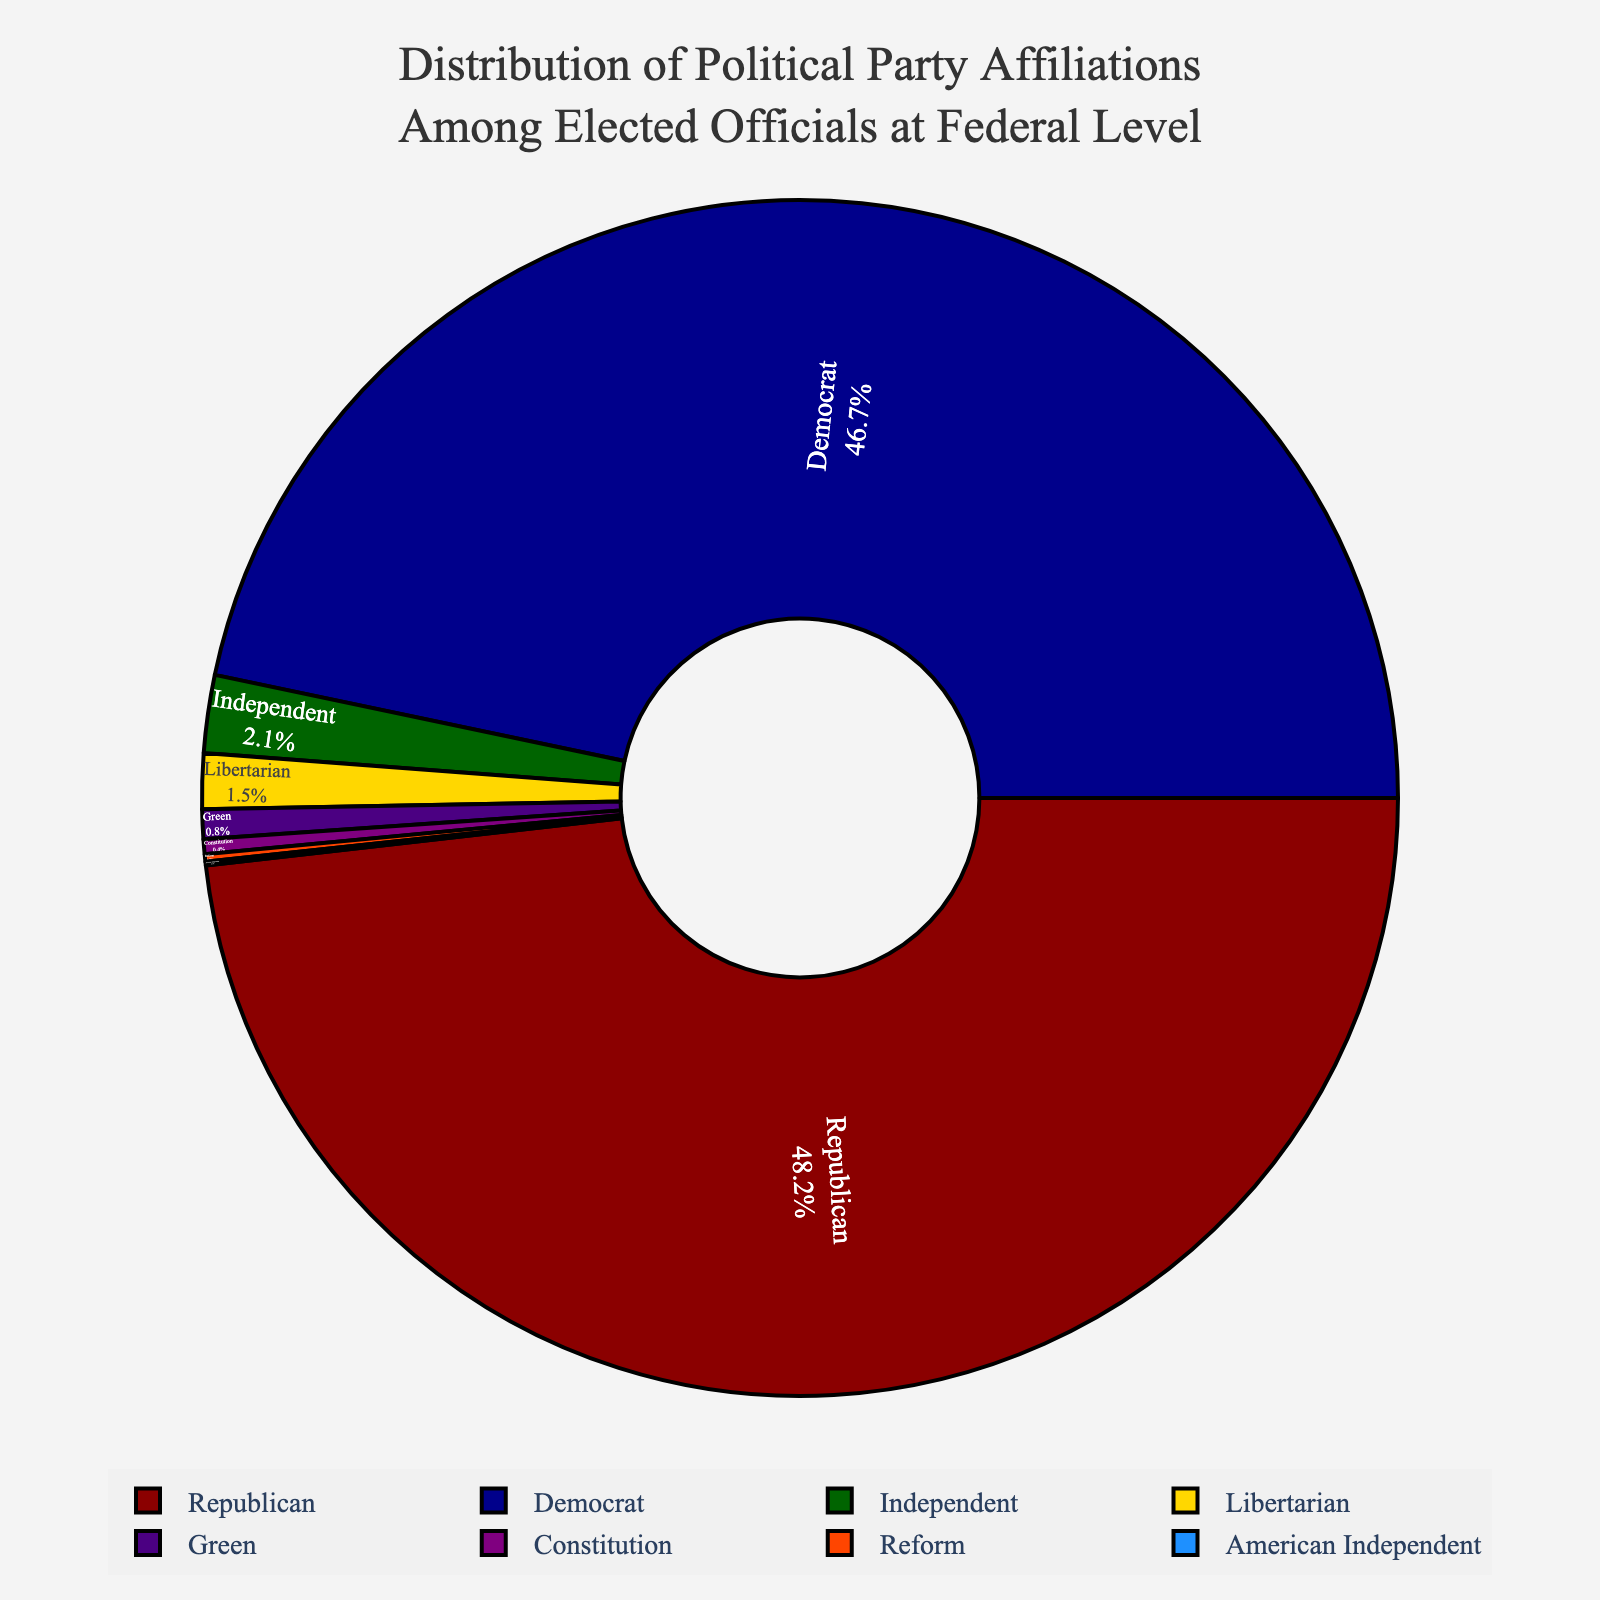What's the total percentage of the Republican and Democrat party affiliations combined? Sum up the percentages for the Republican and Democrat parties. Republican: 48.2%, Democrat: 46.7%, so the total is 48.2% + 46.7% = 94.9%
Answer: 94.9% Which party has the smallest percentage of affiliations among elected officials at the federal level? Identify the party with the smallest percentage in the pie chart. The smallest value is 0.1%, which belongs to the American Independent party.
Answer: American Independent How much larger is the percentage of the Libertarian party compared to the Green party? Subtract the percentage of the Green party from the percentage of the Libertarian party. Libertarian: 1.5%, Green: 0.8%, so the difference is 1.5% - 0.8% = 0.7%
Answer: 0.7% What is the combined percentage of the Independent, Libertarian, Green, Constitution, Reform, and American Independent parties? Sum up the percentages for these parties. Independent: 2.1%, Libertarian: 1.5%, Green: 0.8%, Constitution: 0.4%, Reform: 0.2%, American Independent: 0.1%. Total: 2.1% + 1.5% + 0.8% + 0.4% + 0.2% + 0.1% = 5.1%
Answer: 5.1% How does the percentage of elected officials affiliated with the Republican party compare to the percentage of those affiliated with all minor parties combined (Independent, Libertarian, Green, Constitution, Reform, American Independent)? Calculate the combined percentage of minor parties and compare it with the Republican percentage. Combined minor parties: 5.1%, Republican: 48.2%, so 48.2% is significantly larger than 5.1%
Answer: Republican percentage is significantly larger Which two parties have the closest percentages of affiliations? Compare the percentages and identify the two closest values. Republican: 48.2%, Democrat: 46.7%, Independent: 2.1%, Libertarian: 1.5%, Green: 0.8%, Constitution: 0.4%, Reform: 0.2%, American Independent: 0.1%. The closest values are Republican and Democrat with a difference of 48.2% - 46.7% = 1.5%
Answer: Republican and Democrat What does the pie chart suggest about the dominance of two major parties compared to minor parties? Combine the total percentage for Republican and Democrat, then compare it to the total percentage of minor parties. Republican + Democrat = 94.9%, Minor parties combined = 5.1%. The pie chart shows that the two major parties are overwhelmingly dominant.
Answer: Major parties are overwhelmingly dominant 